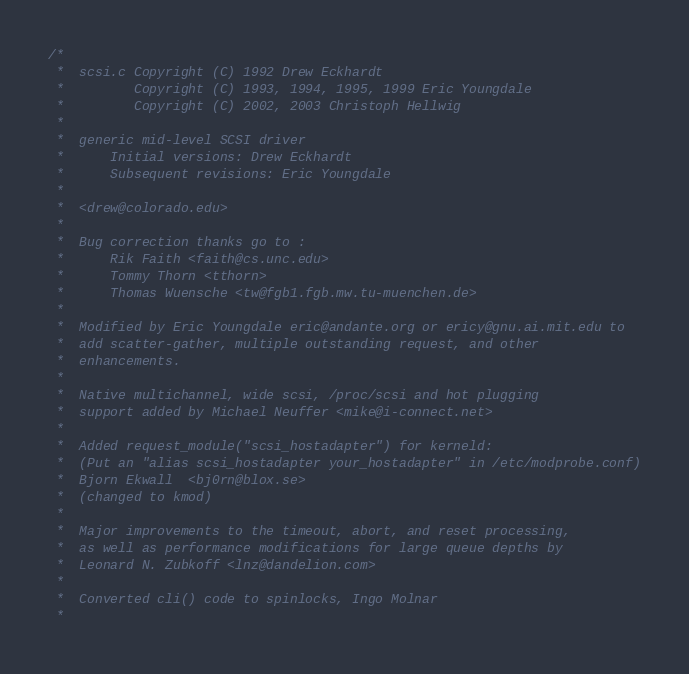Convert code to text. <code><loc_0><loc_0><loc_500><loc_500><_C_>/*
 *  scsi.c Copyright (C) 1992 Drew Eckhardt
 *         Copyright (C) 1993, 1994, 1995, 1999 Eric Youngdale
 *         Copyright (C) 2002, 2003 Christoph Hellwig
 *
 *  generic mid-level SCSI driver
 *      Initial versions: Drew Eckhardt
 *      Subsequent revisions: Eric Youngdale
 *
 *  <drew@colorado.edu>
 *
 *  Bug correction thanks go to :
 *      Rik Faith <faith@cs.unc.edu>
 *      Tommy Thorn <tthorn>
 *      Thomas Wuensche <tw@fgb1.fgb.mw.tu-muenchen.de>
 *
 *  Modified by Eric Youngdale eric@andante.org or ericy@gnu.ai.mit.edu to
 *  add scatter-gather, multiple outstanding request, and other
 *  enhancements.
 *
 *  Native multichannel, wide scsi, /proc/scsi and hot plugging
 *  support added by Michael Neuffer <mike@i-connect.net>
 *
 *  Added request_module("scsi_hostadapter") for kerneld:
 *  (Put an "alias scsi_hostadapter your_hostadapter" in /etc/modprobe.conf)
 *  Bjorn Ekwall  <bj0rn@blox.se>
 *  (changed to kmod)
 *
 *  Major improvements to the timeout, abort, and reset processing,
 *  as well as performance modifications for large queue depths by
 *  Leonard N. Zubkoff <lnz@dandelion.com>
 *
 *  Converted cli() code to spinlocks, Ingo Molnar
 *</code> 